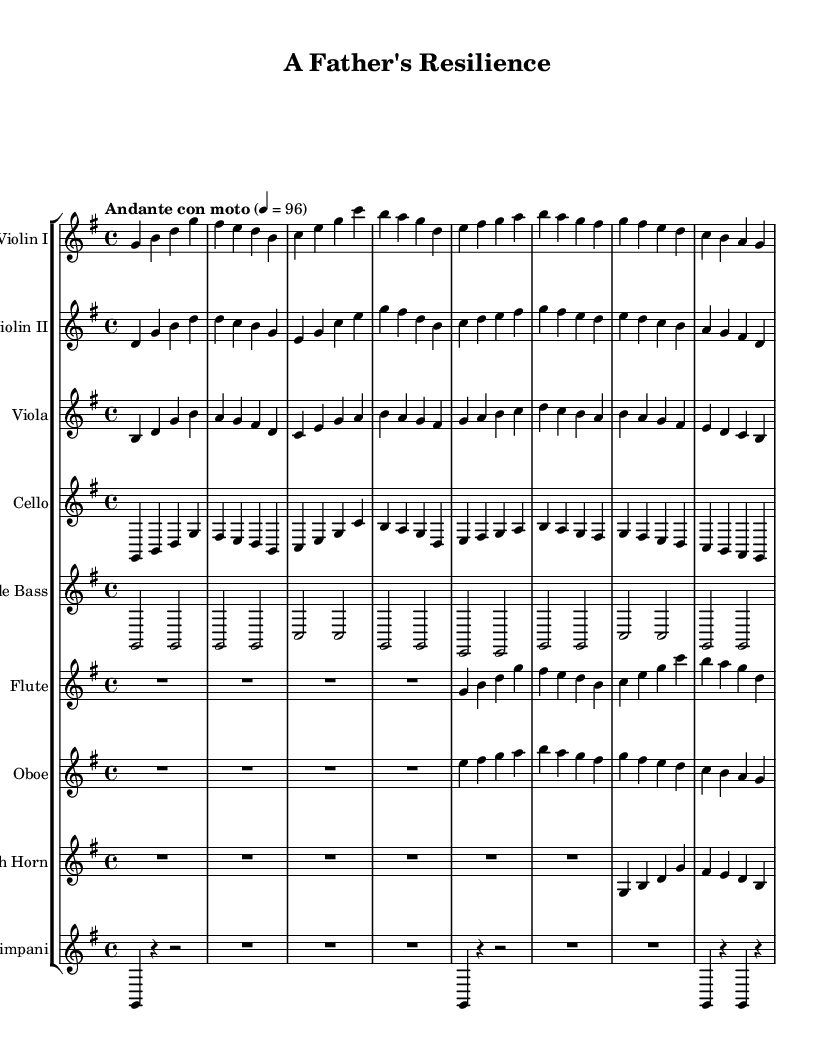What is the key signature of this music? The key signature is G major, which has one sharp (F#). This can be identified by looking at the key signature indicated at the beginning of the score.
Answer: G major What is the time signature of this music? The time signature is 4/4, which indicates that there are four beats in each measure and the quarter note receives one beat. This information is found at the beginning of the score next to the key signature.
Answer: 4/4 What is the tempo marking of this piece? The tempo marking is "Andante con moto," which suggests a moderate pace. The tempo is often indicated above the staff, and here it specifies the character and speed of the piece.
Answer: Andante con moto How many measures are in the first system? There are eight measures in the first system. By counting the bars within the first line of music, you can confirm the total number of measures.
Answer: Eight Which instruments start with a rest? The flute and oboe start with a rest, as indicated by "R1*4" for flute and "R1*4" for oboe, marking their initial silence before they play.
Answer: Flute and Oboe What type of theme does this piece represent? The theme of this piece represents hope and perseverance. This can be inferred from the uplifting melody lines, harmony, and orchestration designed to evoke positive emotions.
Answer: Hope and perseverance Which instrument plays the lowest pitch? The double bass plays the lowest pitch as it is tuned an octave lower than the cello and supports the harmony with its deeper notes indicated in the score.
Answer: Double Bass 